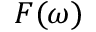Convert formula to latex. <formula><loc_0><loc_0><loc_500><loc_500>F ( \omega )</formula> 